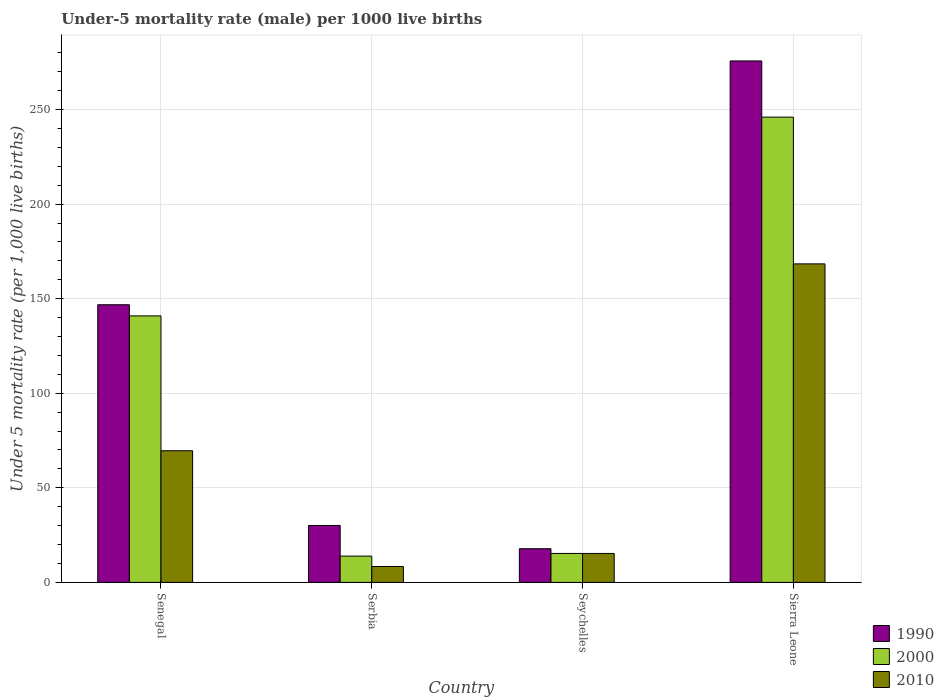How many different coloured bars are there?
Keep it short and to the point. 3. Are the number of bars per tick equal to the number of legend labels?
Provide a short and direct response. Yes. Are the number of bars on each tick of the X-axis equal?
Your answer should be compact. Yes. How many bars are there on the 4th tick from the left?
Provide a succinct answer. 3. What is the label of the 1st group of bars from the left?
Your response must be concise. Senegal. In how many cases, is the number of bars for a given country not equal to the number of legend labels?
Offer a terse response. 0. What is the under-five mortality rate in 1990 in Senegal?
Your answer should be very brief. 146.8. Across all countries, what is the maximum under-five mortality rate in 1990?
Provide a succinct answer. 275.7. Across all countries, what is the minimum under-five mortality rate in 1990?
Offer a terse response. 17.8. In which country was the under-five mortality rate in 2000 maximum?
Offer a very short reply. Sierra Leone. In which country was the under-five mortality rate in 1990 minimum?
Provide a short and direct response. Seychelles. What is the total under-five mortality rate in 2010 in the graph?
Provide a short and direct response. 261.7. What is the difference between the under-five mortality rate in 2010 in Serbia and that in Sierra Leone?
Keep it short and to the point. -160. What is the difference between the under-five mortality rate in 2000 in Serbia and the under-five mortality rate in 1990 in Sierra Leone?
Keep it short and to the point. -261.8. What is the average under-five mortality rate in 2000 per country?
Make the answer very short. 104.03. What is the difference between the under-five mortality rate of/in 2010 and under-five mortality rate of/in 1990 in Serbia?
Your answer should be very brief. -21.7. What is the ratio of the under-five mortality rate in 1990 in Senegal to that in Serbia?
Your response must be concise. 4.88. Is the difference between the under-five mortality rate in 2010 in Serbia and Sierra Leone greater than the difference between the under-five mortality rate in 1990 in Serbia and Sierra Leone?
Your response must be concise. Yes. What is the difference between the highest and the second highest under-five mortality rate in 2010?
Ensure brevity in your answer.  98.8. What is the difference between the highest and the lowest under-five mortality rate in 2000?
Offer a terse response. 232.1. What does the 3rd bar from the left in Senegal represents?
Your response must be concise. 2010. Are all the bars in the graph horizontal?
Provide a short and direct response. No. How many countries are there in the graph?
Provide a short and direct response. 4. Are the values on the major ticks of Y-axis written in scientific E-notation?
Offer a very short reply. No. Where does the legend appear in the graph?
Offer a very short reply. Bottom right. How are the legend labels stacked?
Provide a succinct answer. Vertical. What is the title of the graph?
Your answer should be very brief. Under-5 mortality rate (male) per 1000 live births. Does "2006" appear as one of the legend labels in the graph?
Make the answer very short. No. What is the label or title of the X-axis?
Offer a terse response. Country. What is the label or title of the Y-axis?
Your answer should be very brief. Under 5 mortality rate (per 1,0 live births). What is the Under 5 mortality rate (per 1,000 live births) of 1990 in Senegal?
Keep it short and to the point. 146.8. What is the Under 5 mortality rate (per 1,000 live births) in 2000 in Senegal?
Keep it short and to the point. 140.9. What is the Under 5 mortality rate (per 1,000 live births) of 2010 in Senegal?
Make the answer very short. 69.6. What is the Under 5 mortality rate (per 1,000 live births) in 1990 in Serbia?
Keep it short and to the point. 30.1. What is the Under 5 mortality rate (per 1,000 live births) of 2000 in Serbia?
Offer a terse response. 13.9. What is the Under 5 mortality rate (per 1,000 live births) of 1990 in Seychelles?
Make the answer very short. 17.8. What is the Under 5 mortality rate (per 1,000 live births) in 2000 in Seychelles?
Offer a terse response. 15.3. What is the Under 5 mortality rate (per 1,000 live births) of 2010 in Seychelles?
Your response must be concise. 15.3. What is the Under 5 mortality rate (per 1,000 live births) in 1990 in Sierra Leone?
Ensure brevity in your answer.  275.7. What is the Under 5 mortality rate (per 1,000 live births) of 2000 in Sierra Leone?
Your response must be concise. 246. What is the Under 5 mortality rate (per 1,000 live births) in 2010 in Sierra Leone?
Your response must be concise. 168.4. Across all countries, what is the maximum Under 5 mortality rate (per 1,000 live births) in 1990?
Your answer should be very brief. 275.7. Across all countries, what is the maximum Under 5 mortality rate (per 1,000 live births) in 2000?
Make the answer very short. 246. Across all countries, what is the maximum Under 5 mortality rate (per 1,000 live births) in 2010?
Provide a succinct answer. 168.4. Across all countries, what is the minimum Under 5 mortality rate (per 1,000 live births) in 1990?
Your answer should be very brief. 17.8. Across all countries, what is the minimum Under 5 mortality rate (per 1,000 live births) in 2000?
Provide a short and direct response. 13.9. Across all countries, what is the minimum Under 5 mortality rate (per 1,000 live births) of 2010?
Offer a very short reply. 8.4. What is the total Under 5 mortality rate (per 1,000 live births) of 1990 in the graph?
Your answer should be very brief. 470.4. What is the total Under 5 mortality rate (per 1,000 live births) of 2000 in the graph?
Offer a very short reply. 416.1. What is the total Under 5 mortality rate (per 1,000 live births) in 2010 in the graph?
Offer a terse response. 261.7. What is the difference between the Under 5 mortality rate (per 1,000 live births) in 1990 in Senegal and that in Serbia?
Offer a terse response. 116.7. What is the difference between the Under 5 mortality rate (per 1,000 live births) in 2000 in Senegal and that in Serbia?
Provide a short and direct response. 127. What is the difference between the Under 5 mortality rate (per 1,000 live births) in 2010 in Senegal and that in Serbia?
Offer a terse response. 61.2. What is the difference between the Under 5 mortality rate (per 1,000 live births) in 1990 in Senegal and that in Seychelles?
Your answer should be very brief. 129. What is the difference between the Under 5 mortality rate (per 1,000 live births) of 2000 in Senegal and that in Seychelles?
Ensure brevity in your answer.  125.6. What is the difference between the Under 5 mortality rate (per 1,000 live births) in 2010 in Senegal and that in Seychelles?
Your response must be concise. 54.3. What is the difference between the Under 5 mortality rate (per 1,000 live births) of 1990 in Senegal and that in Sierra Leone?
Your answer should be compact. -128.9. What is the difference between the Under 5 mortality rate (per 1,000 live births) of 2000 in Senegal and that in Sierra Leone?
Make the answer very short. -105.1. What is the difference between the Under 5 mortality rate (per 1,000 live births) in 2010 in Senegal and that in Sierra Leone?
Give a very brief answer. -98.8. What is the difference between the Under 5 mortality rate (per 1,000 live births) in 2010 in Serbia and that in Seychelles?
Ensure brevity in your answer.  -6.9. What is the difference between the Under 5 mortality rate (per 1,000 live births) in 1990 in Serbia and that in Sierra Leone?
Offer a terse response. -245.6. What is the difference between the Under 5 mortality rate (per 1,000 live births) in 2000 in Serbia and that in Sierra Leone?
Your response must be concise. -232.1. What is the difference between the Under 5 mortality rate (per 1,000 live births) of 2010 in Serbia and that in Sierra Leone?
Offer a very short reply. -160. What is the difference between the Under 5 mortality rate (per 1,000 live births) in 1990 in Seychelles and that in Sierra Leone?
Make the answer very short. -257.9. What is the difference between the Under 5 mortality rate (per 1,000 live births) in 2000 in Seychelles and that in Sierra Leone?
Provide a succinct answer. -230.7. What is the difference between the Under 5 mortality rate (per 1,000 live births) in 2010 in Seychelles and that in Sierra Leone?
Make the answer very short. -153.1. What is the difference between the Under 5 mortality rate (per 1,000 live births) of 1990 in Senegal and the Under 5 mortality rate (per 1,000 live births) of 2000 in Serbia?
Your answer should be very brief. 132.9. What is the difference between the Under 5 mortality rate (per 1,000 live births) of 1990 in Senegal and the Under 5 mortality rate (per 1,000 live births) of 2010 in Serbia?
Keep it short and to the point. 138.4. What is the difference between the Under 5 mortality rate (per 1,000 live births) of 2000 in Senegal and the Under 5 mortality rate (per 1,000 live births) of 2010 in Serbia?
Offer a terse response. 132.5. What is the difference between the Under 5 mortality rate (per 1,000 live births) of 1990 in Senegal and the Under 5 mortality rate (per 1,000 live births) of 2000 in Seychelles?
Offer a very short reply. 131.5. What is the difference between the Under 5 mortality rate (per 1,000 live births) of 1990 in Senegal and the Under 5 mortality rate (per 1,000 live births) of 2010 in Seychelles?
Ensure brevity in your answer.  131.5. What is the difference between the Under 5 mortality rate (per 1,000 live births) in 2000 in Senegal and the Under 5 mortality rate (per 1,000 live births) in 2010 in Seychelles?
Your answer should be very brief. 125.6. What is the difference between the Under 5 mortality rate (per 1,000 live births) in 1990 in Senegal and the Under 5 mortality rate (per 1,000 live births) in 2000 in Sierra Leone?
Offer a very short reply. -99.2. What is the difference between the Under 5 mortality rate (per 1,000 live births) of 1990 in Senegal and the Under 5 mortality rate (per 1,000 live births) of 2010 in Sierra Leone?
Ensure brevity in your answer.  -21.6. What is the difference between the Under 5 mortality rate (per 1,000 live births) in 2000 in Senegal and the Under 5 mortality rate (per 1,000 live births) in 2010 in Sierra Leone?
Give a very brief answer. -27.5. What is the difference between the Under 5 mortality rate (per 1,000 live births) in 1990 in Serbia and the Under 5 mortality rate (per 1,000 live births) in 2000 in Seychelles?
Keep it short and to the point. 14.8. What is the difference between the Under 5 mortality rate (per 1,000 live births) of 1990 in Serbia and the Under 5 mortality rate (per 1,000 live births) of 2010 in Seychelles?
Make the answer very short. 14.8. What is the difference between the Under 5 mortality rate (per 1,000 live births) in 2000 in Serbia and the Under 5 mortality rate (per 1,000 live births) in 2010 in Seychelles?
Offer a terse response. -1.4. What is the difference between the Under 5 mortality rate (per 1,000 live births) in 1990 in Serbia and the Under 5 mortality rate (per 1,000 live births) in 2000 in Sierra Leone?
Offer a terse response. -215.9. What is the difference between the Under 5 mortality rate (per 1,000 live births) in 1990 in Serbia and the Under 5 mortality rate (per 1,000 live births) in 2010 in Sierra Leone?
Your answer should be compact. -138.3. What is the difference between the Under 5 mortality rate (per 1,000 live births) of 2000 in Serbia and the Under 5 mortality rate (per 1,000 live births) of 2010 in Sierra Leone?
Make the answer very short. -154.5. What is the difference between the Under 5 mortality rate (per 1,000 live births) of 1990 in Seychelles and the Under 5 mortality rate (per 1,000 live births) of 2000 in Sierra Leone?
Offer a terse response. -228.2. What is the difference between the Under 5 mortality rate (per 1,000 live births) in 1990 in Seychelles and the Under 5 mortality rate (per 1,000 live births) in 2010 in Sierra Leone?
Make the answer very short. -150.6. What is the difference between the Under 5 mortality rate (per 1,000 live births) of 2000 in Seychelles and the Under 5 mortality rate (per 1,000 live births) of 2010 in Sierra Leone?
Offer a terse response. -153.1. What is the average Under 5 mortality rate (per 1,000 live births) of 1990 per country?
Ensure brevity in your answer.  117.6. What is the average Under 5 mortality rate (per 1,000 live births) in 2000 per country?
Provide a succinct answer. 104.03. What is the average Under 5 mortality rate (per 1,000 live births) in 2010 per country?
Offer a very short reply. 65.42. What is the difference between the Under 5 mortality rate (per 1,000 live births) of 1990 and Under 5 mortality rate (per 1,000 live births) of 2010 in Senegal?
Make the answer very short. 77.2. What is the difference between the Under 5 mortality rate (per 1,000 live births) in 2000 and Under 5 mortality rate (per 1,000 live births) in 2010 in Senegal?
Offer a terse response. 71.3. What is the difference between the Under 5 mortality rate (per 1,000 live births) of 1990 and Under 5 mortality rate (per 1,000 live births) of 2010 in Serbia?
Keep it short and to the point. 21.7. What is the difference between the Under 5 mortality rate (per 1,000 live births) in 2000 and Under 5 mortality rate (per 1,000 live births) in 2010 in Serbia?
Your answer should be very brief. 5.5. What is the difference between the Under 5 mortality rate (per 1,000 live births) of 1990 and Under 5 mortality rate (per 1,000 live births) of 2000 in Seychelles?
Provide a short and direct response. 2.5. What is the difference between the Under 5 mortality rate (per 1,000 live births) of 1990 and Under 5 mortality rate (per 1,000 live births) of 2010 in Seychelles?
Provide a succinct answer. 2.5. What is the difference between the Under 5 mortality rate (per 1,000 live births) of 2000 and Under 5 mortality rate (per 1,000 live births) of 2010 in Seychelles?
Make the answer very short. 0. What is the difference between the Under 5 mortality rate (per 1,000 live births) of 1990 and Under 5 mortality rate (per 1,000 live births) of 2000 in Sierra Leone?
Your answer should be compact. 29.7. What is the difference between the Under 5 mortality rate (per 1,000 live births) of 1990 and Under 5 mortality rate (per 1,000 live births) of 2010 in Sierra Leone?
Provide a short and direct response. 107.3. What is the difference between the Under 5 mortality rate (per 1,000 live births) in 2000 and Under 5 mortality rate (per 1,000 live births) in 2010 in Sierra Leone?
Your response must be concise. 77.6. What is the ratio of the Under 5 mortality rate (per 1,000 live births) of 1990 in Senegal to that in Serbia?
Provide a succinct answer. 4.88. What is the ratio of the Under 5 mortality rate (per 1,000 live births) of 2000 in Senegal to that in Serbia?
Provide a succinct answer. 10.14. What is the ratio of the Under 5 mortality rate (per 1,000 live births) of 2010 in Senegal to that in Serbia?
Keep it short and to the point. 8.29. What is the ratio of the Under 5 mortality rate (per 1,000 live births) of 1990 in Senegal to that in Seychelles?
Offer a terse response. 8.25. What is the ratio of the Under 5 mortality rate (per 1,000 live births) of 2000 in Senegal to that in Seychelles?
Keep it short and to the point. 9.21. What is the ratio of the Under 5 mortality rate (per 1,000 live births) of 2010 in Senegal to that in Seychelles?
Give a very brief answer. 4.55. What is the ratio of the Under 5 mortality rate (per 1,000 live births) of 1990 in Senegal to that in Sierra Leone?
Give a very brief answer. 0.53. What is the ratio of the Under 5 mortality rate (per 1,000 live births) in 2000 in Senegal to that in Sierra Leone?
Provide a short and direct response. 0.57. What is the ratio of the Under 5 mortality rate (per 1,000 live births) of 2010 in Senegal to that in Sierra Leone?
Provide a succinct answer. 0.41. What is the ratio of the Under 5 mortality rate (per 1,000 live births) in 1990 in Serbia to that in Seychelles?
Your answer should be very brief. 1.69. What is the ratio of the Under 5 mortality rate (per 1,000 live births) in 2000 in Serbia to that in Seychelles?
Keep it short and to the point. 0.91. What is the ratio of the Under 5 mortality rate (per 1,000 live births) in 2010 in Serbia to that in Seychelles?
Ensure brevity in your answer.  0.55. What is the ratio of the Under 5 mortality rate (per 1,000 live births) of 1990 in Serbia to that in Sierra Leone?
Provide a short and direct response. 0.11. What is the ratio of the Under 5 mortality rate (per 1,000 live births) of 2000 in Serbia to that in Sierra Leone?
Provide a short and direct response. 0.06. What is the ratio of the Under 5 mortality rate (per 1,000 live births) in 2010 in Serbia to that in Sierra Leone?
Offer a terse response. 0.05. What is the ratio of the Under 5 mortality rate (per 1,000 live births) in 1990 in Seychelles to that in Sierra Leone?
Offer a terse response. 0.06. What is the ratio of the Under 5 mortality rate (per 1,000 live births) of 2000 in Seychelles to that in Sierra Leone?
Keep it short and to the point. 0.06. What is the ratio of the Under 5 mortality rate (per 1,000 live births) of 2010 in Seychelles to that in Sierra Leone?
Keep it short and to the point. 0.09. What is the difference between the highest and the second highest Under 5 mortality rate (per 1,000 live births) of 1990?
Make the answer very short. 128.9. What is the difference between the highest and the second highest Under 5 mortality rate (per 1,000 live births) in 2000?
Offer a terse response. 105.1. What is the difference between the highest and the second highest Under 5 mortality rate (per 1,000 live births) of 2010?
Ensure brevity in your answer.  98.8. What is the difference between the highest and the lowest Under 5 mortality rate (per 1,000 live births) in 1990?
Offer a terse response. 257.9. What is the difference between the highest and the lowest Under 5 mortality rate (per 1,000 live births) of 2000?
Make the answer very short. 232.1. What is the difference between the highest and the lowest Under 5 mortality rate (per 1,000 live births) of 2010?
Your answer should be very brief. 160. 